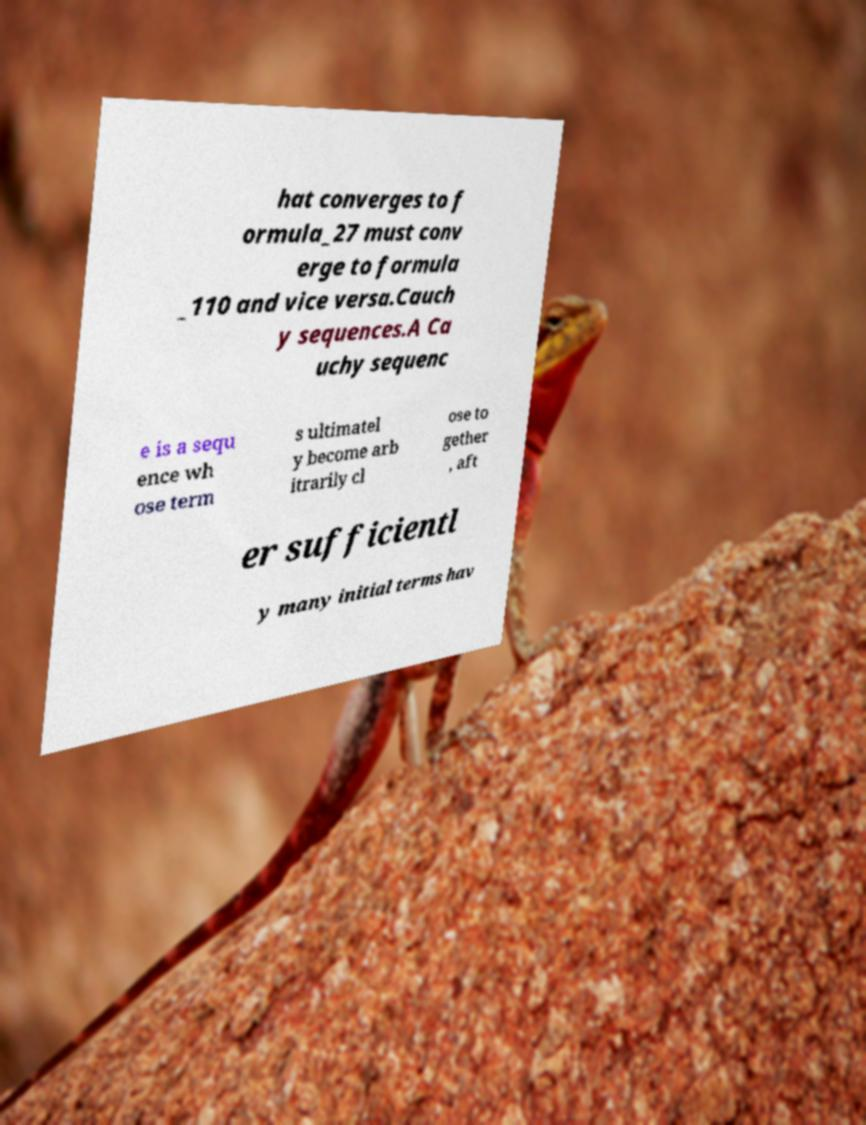Can you accurately transcribe the text from the provided image for me? hat converges to f ormula_27 must conv erge to formula _110 and vice versa.Cauch y sequences.A Ca uchy sequenc e is a sequ ence wh ose term s ultimatel y become arb itrarily cl ose to gether , aft er sufficientl y many initial terms hav 